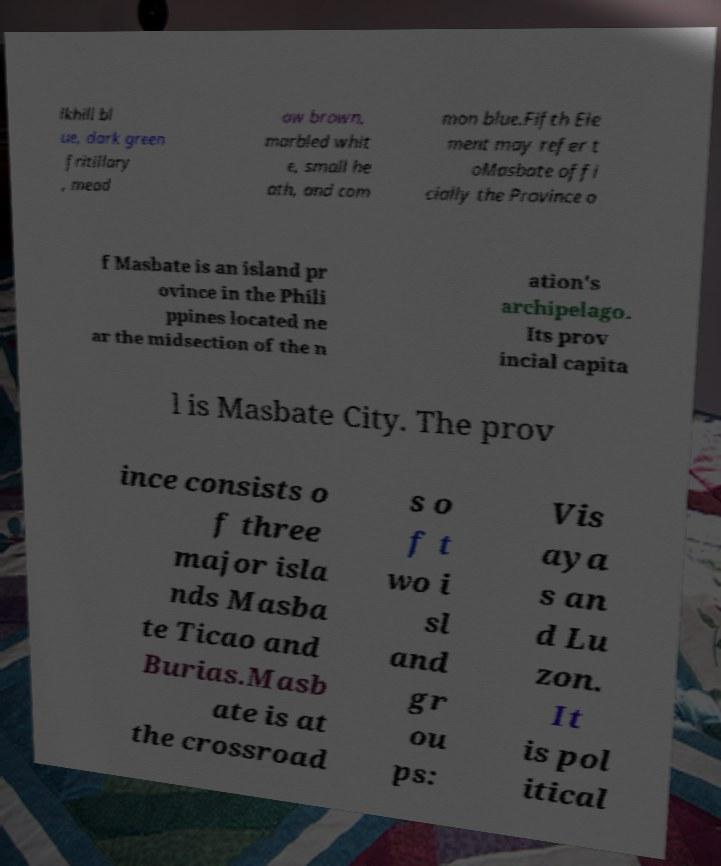What messages or text are displayed in this image? I need them in a readable, typed format. lkhill bl ue, dark green fritillary , mead ow brown, marbled whit e, small he ath, and com mon blue.Fifth Ele ment may refer t oMasbate offi cially the Province o f Masbate is an island pr ovince in the Phili ppines located ne ar the midsection of the n ation's archipelago. Its prov incial capita l is Masbate City. The prov ince consists o f three major isla nds Masba te Ticao and Burias.Masb ate is at the crossroad s o f t wo i sl and gr ou ps: Vis aya s an d Lu zon. It is pol itical 